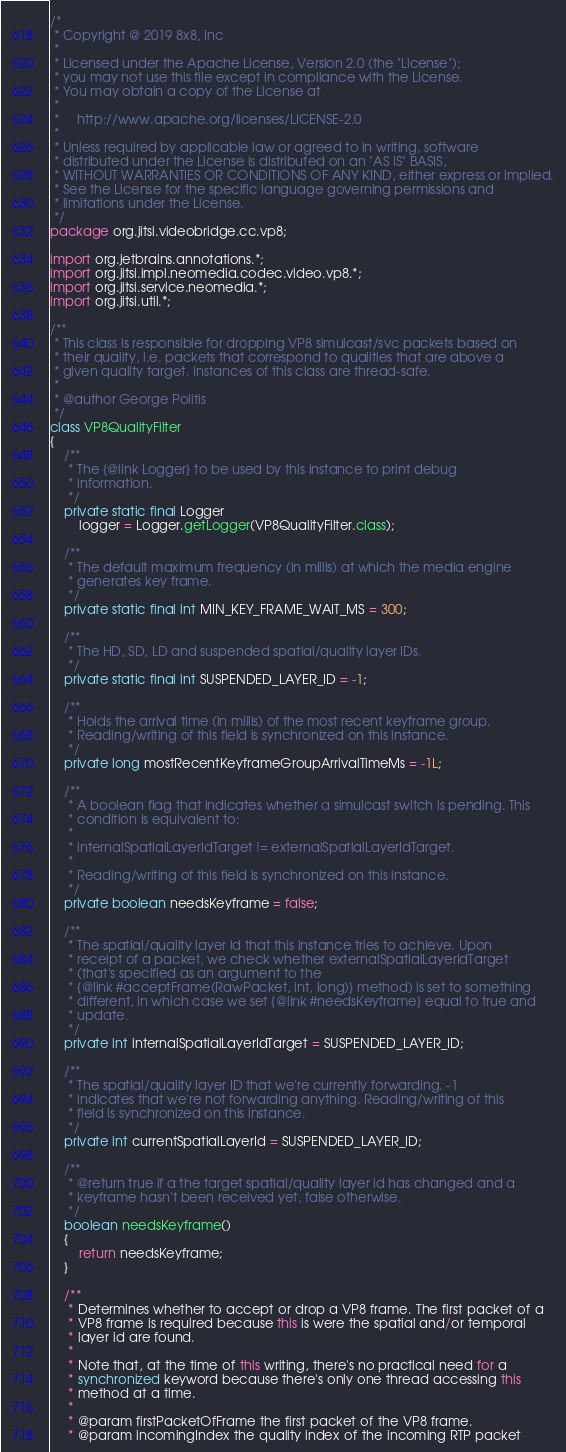<code> <loc_0><loc_0><loc_500><loc_500><_Java_>/*
 * Copyright @ 2019 8x8, Inc
 *
 * Licensed under the Apache License, Version 2.0 (the "License");
 * you may not use this file except in compliance with the License.
 * You may obtain a copy of the License at
 *
 *     http://www.apache.org/licenses/LICENSE-2.0
 *
 * Unless required by applicable law or agreed to in writing, software
 * distributed under the License is distributed on an "AS IS" BASIS,
 * WITHOUT WARRANTIES OR CONDITIONS OF ANY KIND, either express or implied.
 * See the License for the specific language governing permissions and
 * limitations under the License.
 */
package org.jitsi.videobridge.cc.vp8;

import org.jetbrains.annotations.*;
import org.jitsi.impl.neomedia.codec.video.vp8.*;
import org.jitsi.service.neomedia.*;
import org.jitsi.util.*;

/**
 * This class is responsible for dropping VP8 simulcast/svc packets based on
 * their quality, i.e. packets that correspond to qualities that are above a
 * given quality target. Instances of this class are thread-safe.
 *
 * @author George Politis
 */
class VP8QualityFilter
{
    /**
     * The {@link Logger} to be used by this instance to print debug
     * information.
     */
    private static final Logger
        logger = Logger.getLogger(VP8QualityFilter.class);

    /**
     * The default maximum frequency (in millis) at which the media engine
     * generates key frame.
     */
    private static final int MIN_KEY_FRAME_WAIT_MS = 300;

    /**
     * The HD, SD, LD and suspended spatial/quality layer IDs.
     */
    private static final int SUSPENDED_LAYER_ID = -1;

    /**
     * Holds the arrival time (in millis) of the most recent keyframe group.
     * Reading/writing of this field is synchronized on this instance.
     */
    private long mostRecentKeyframeGroupArrivalTimeMs = -1L;

    /**
     * A boolean flag that indicates whether a simulcast switch is pending. This
     * condition is equivalent to:
     *
     * internalSpatialLayerIdTarget != externalSpatialLayerIdTarget.
     *
     * Reading/writing of this field is synchronized on this instance.
     */
    private boolean needsKeyframe = false;

    /**
     * The spatial/quality layer id that this instance tries to achieve. Upon
     * receipt of a packet, we check whether externalSpatialLayerIdTarget
     * (that's specified as an argument to the
     * {@link #acceptFrame(RawPacket, int, long)} method) is set to something
     * different, in which case we set {@link #needsKeyframe} equal to true and
     * update.
     */
    private int internalSpatialLayerIdTarget = SUSPENDED_LAYER_ID;

    /**
     * The spatial/quality layer ID that we're currently forwarding. -1
     * indicates that we're not forwarding anything. Reading/writing of this
     * field is synchronized on this instance.
     */
    private int currentSpatialLayerId = SUSPENDED_LAYER_ID;

    /**
     * @return true if a the target spatial/quality layer id has changed and a
     * keyframe hasn't been received yet, false otherwise.
     */
    boolean needsKeyframe()
    {
        return needsKeyframe;
    }

    /**
     * Determines whether to accept or drop a VP8 frame. The first packet of a
     * VP8 frame is required because this is were the spatial and/or temporal
     * layer id are found.
     *
     * Note that, at the time of this writing, there's no practical need for a
     * synchronized keyword because there's only one thread accessing this
     * method at a time.
     *
     * @param firstPacketOfFrame the first packet of the VP8 frame.
     * @param incomingIndex the quality index of the incoming RTP packet</code> 